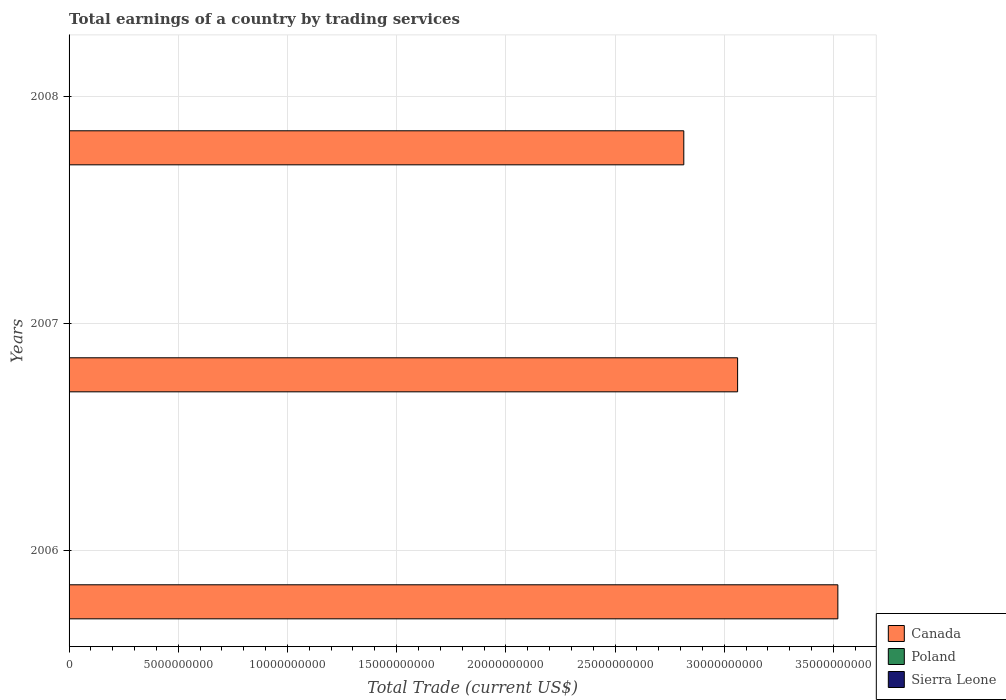What is the label of the 1st group of bars from the top?
Your answer should be very brief. 2008. What is the total earnings in Canada in 2006?
Your answer should be very brief. 3.52e+1. Across all years, what is the maximum total earnings in Canada?
Make the answer very short. 3.52e+1. Across all years, what is the minimum total earnings in Sierra Leone?
Your answer should be compact. 0. In which year was the total earnings in Canada maximum?
Offer a very short reply. 2006. What is the total total earnings in Poland in the graph?
Keep it short and to the point. 0. What is the difference between the total earnings in Canada in 2006 and that in 2008?
Your answer should be very brief. 7.05e+09. What is the average total earnings in Canada per year?
Provide a succinct answer. 3.13e+1. What is the ratio of the total earnings in Canada in 2006 to that in 2008?
Ensure brevity in your answer.  1.25. Is the total earnings in Canada in 2006 less than that in 2008?
Your answer should be very brief. No. What is the difference between the highest and the second highest total earnings in Canada?
Make the answer very short. 4.59e+09. What is the difference between the highest and the lowest total earnings in Canada?
Provide a short and direct response. 7.05e+09. Is it the case that in every year, the sum of the total earnings in Sierra Leone and total earnings in Poland is greater than the total earnings in Canada?
Your response must be concise. No. How many bars are there?
Give a very brief answer. 3. Are all the bars in the graph horizontal?
Give a very brief answer. Yes. How many years are there in the graph?
Your answer should be compact. 3. What is the difference between two consecutive major ticks on the X-axis?
Offer a very short reply. 5.00e+09. Are the values on the major ticks of X-axis written in scientific E-notation?
Give a very brief answer. No. Where does the legend appear in the graph?
Make the answer very short. Bottom right. How are the legend labels stacked?
Provide a short and direct response. Vertical. What is the title of the graph?
Provide a succinct answer. Total earnings of a country by trading services. Does "Slovenia" appear as one of the legend labels in the graph?
Your answer should be compact. No. What is the label or title of the X-axis?
Ensure brevity in your answer.  Total Trade (current US$). What is the Total Trade (current US$) of Canada in 2006?
Offer a very short reply. 3.52e+1. What is the Total Trade (current US$) of Sierra Leone in 2006?
Provide a short and direct response. 0. What is the Total Trade (current US$) of Canada in 2007?
Keep it short and to the point. 3.06e+1. What is the Total Trade (current US$) in Sierra Leone in 2007?
Provide a short and direct response. 0. What is the Total Trade (current US$) of Canada in 2008?
Offer a terse response. 2.81e+1. Across all years, what is the maximum Total Trade (current US$) in Canada?
Provide a succinct answer. 3.52e+1. Across all years, what is the minimum Total Trade (current US$) of Canada?
Your response must be concise. 2.81e+1. What is the total Total Trade (current US$) in Canada in the graph?
Keep it short and to the point. 9.40e+1. What is the difference between the Total Trade (current US$) of Canada in 2006 and that in 2007?
Your answer should be very brief. 4.59e+09. What is the difference between the Total Trade (current US$) in Canada in 2006 and that in 2008?
Give a very brief answer. 7.05e+09. What is the difference between the Total Trade (current US$) in Canada in 2007 and that in 2008?
Your answer should be very brief. 2.46e+09. What is the average Total Trade (current US$) of Canada per year?
Provide a short and direct response. 3.13e+1. What is the ratio of the Total Trade (current US$) of Canada in 2006 to that in 2007?
Your answer should be very brief. 1.15. What is the ratio of the Total Trade (current US$) of Canada in 2006 to that in 2008?
Make the answer very short. 1.25. What is the ratio of the Total Trade (current US$) of Canada in 2007 to that in 2008?
Offer a very short reply. 1.09. What is the difference between the highest and the second highest Total Trade (current US$) of Canada?
Provide a short and direct response. 4.59e+09. What is the difference between the highest and the lowest Total Trade (current US$) in Canada?
Keep it short and to the point. 7.05e+09. 